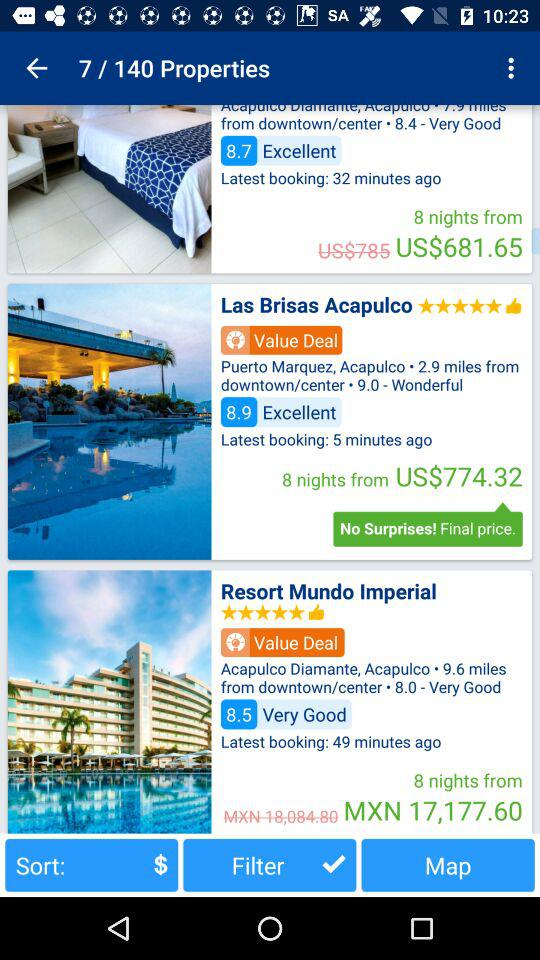What is the starting price for 8 nights in "Las Brisas Acapulco"? The starting price for 8 nights in "Las Brisas Acapulco" is US$774.32. 